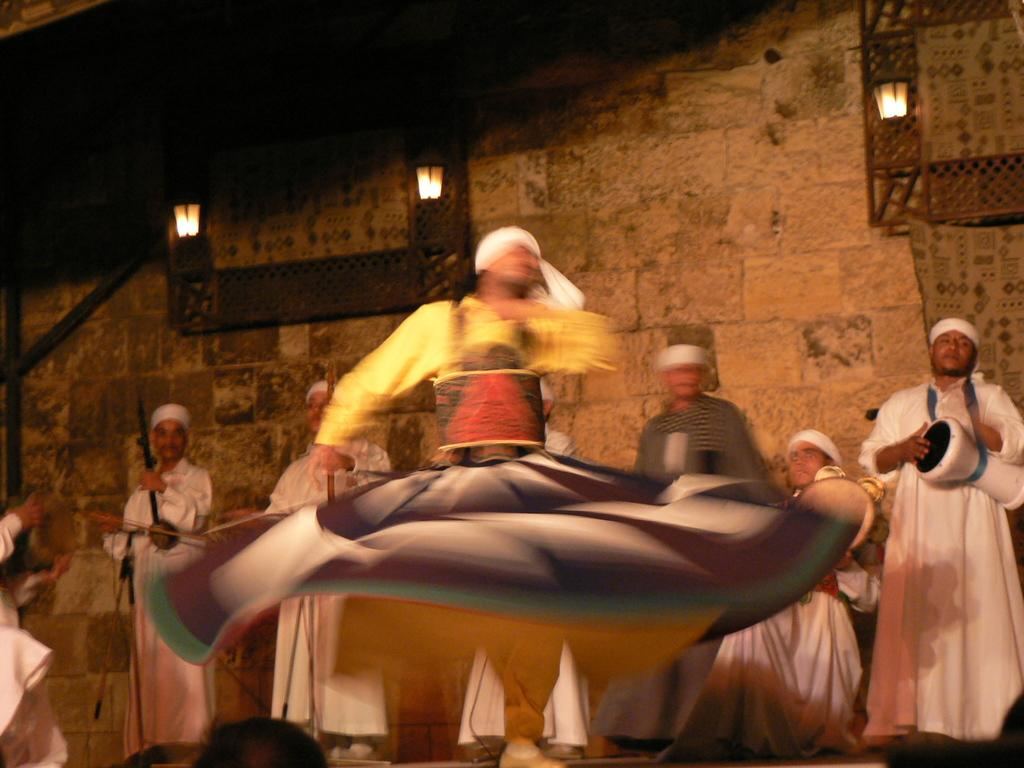What is the main action being performed by the person in the image? There is a person dancing in the image. What can be seen in the background of the image? There are people holding musical instruments in the background, and they are playing them. What is the setting of the image? There is a wall visible in the background. What type of cap is the person wearing while dancing in the image? There is no cap visible in the image; the person is not wearing one. How much was the payment for the musical instruments in the image? There is no indication of payment in the image; it only shows people playing musical instruments. 